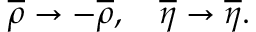Convert formula to latex. <formula><loc_0><loc_0><loc_500><loc_500>\overline { \rho } \to - \overline { \rho } , \quad \overline { \eta } \to \overline { \eta } .</formula> 